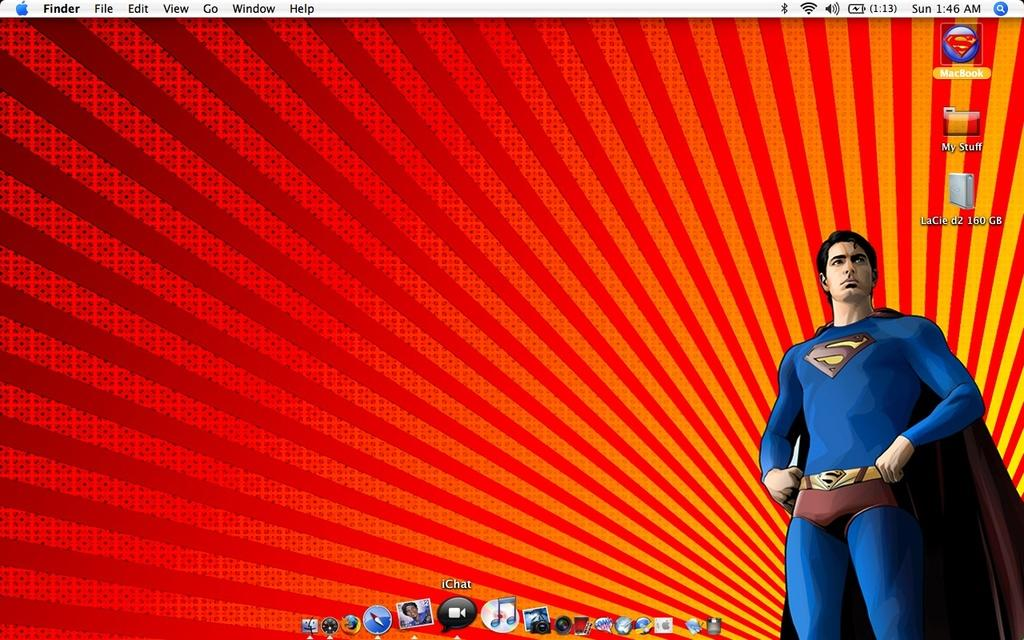What type of character is in the image? There is an animated man in the image. What is the animated man wearing? The man is wearing a costume. What can be seen on the desktop screen in the image? There are icons visible on a desktop screen. What type of grass can be seen growing on the hill in the image? There is no hill or grass present in the image; it features an animated man wearing a costume and icons on a desktop screen. 